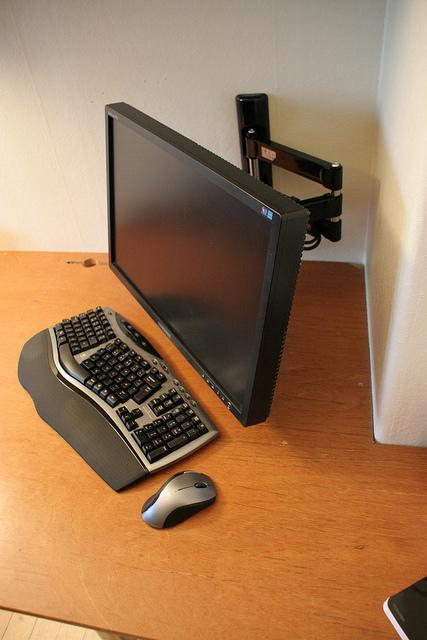How many women are there?
Give a very brief answer. 0. 